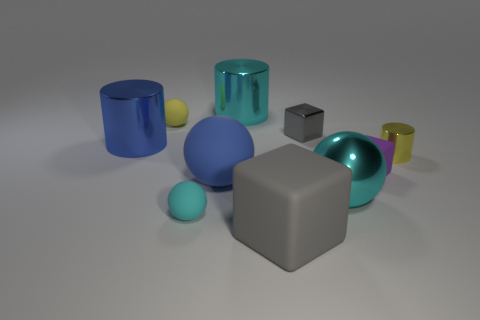Subtract all spheres. How many objects are left? 6 Add 1 big blue metal objects. How many big blue metal objects exist? 2 Subtract 0 red balls. How many objects are left? 10 Subtract all purple matte objects. Subtract all green rubber cylinders. How many objects are left? 9 Add 8 small yellow rubber spheres. How many small yellow rubber spheres are left? 9 